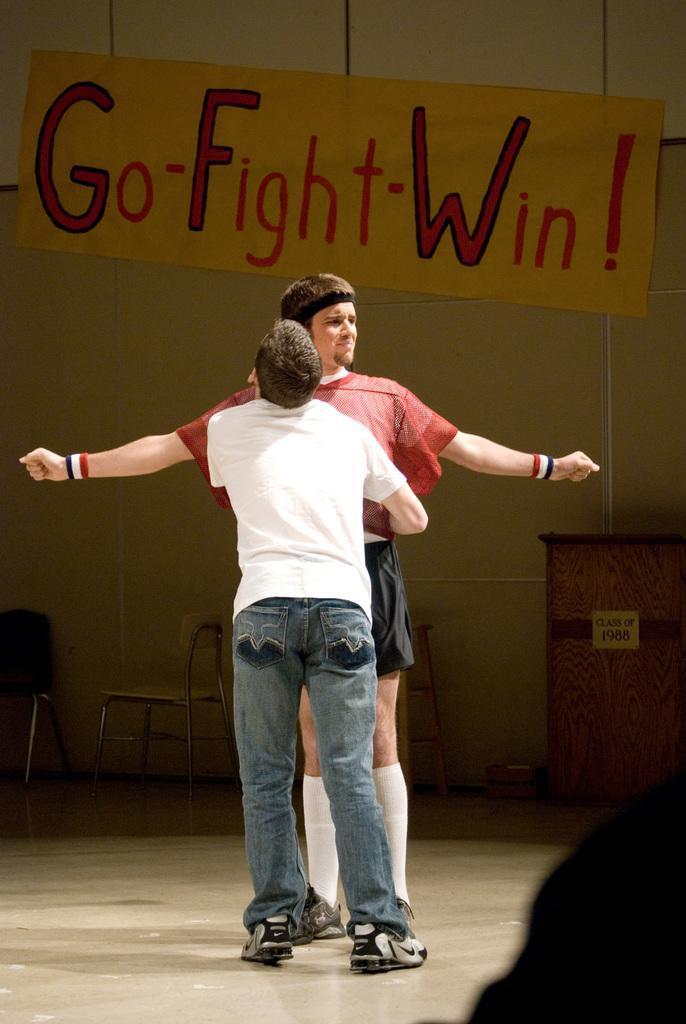Can you describe this image briefly? In this image in the center there are two persons who are standing, and in the background there are some chairs and board. On the board there is some text and a wall, on the right side there is a table. At the bottom there is floor. 